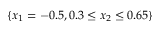Convert formula to latex. <formula><loc_0><loc_0><loc_500><loc_500>\{ x _ { 1 } = - 0 . 5 , 0 . 3 \leq x _ { 2 } \leq 0 . 6 5 \}</formula> 